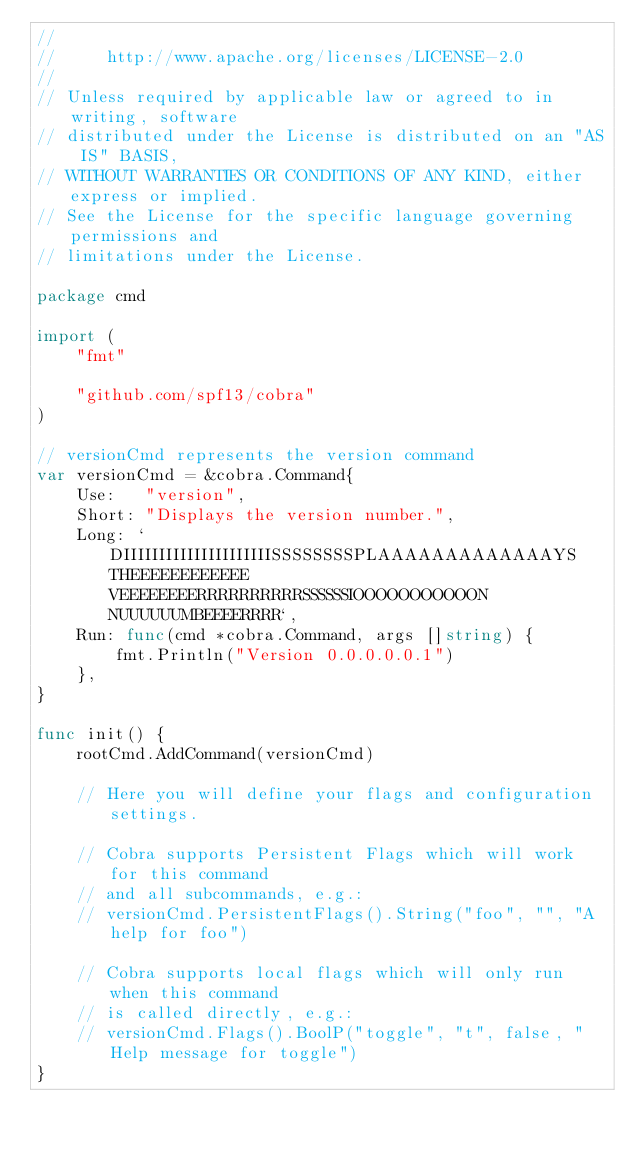<code> <loc_0><loc_0><loc_500><loc_500><_Go_>//
//     http://www.apache.org/licenses/LICENSE-2.0
//
// Unless required by applicable law or agreed to in writing, software
// distributed under the License is distributed on an "AS IS" BASIS,
// WITHOUT WARRANTIES OR CONDITIONS OF ANY KIND, either express or implied.
// See the License for the specific language governing permissions and
// limitations under the License.

package cmd

import (
	"fmt"

	"github.com/spf13/cobra"
)

// versionCmd represents the version command
var versionCmd = &cobra.Command{
	Use:   "version",
	Short: "Displays the version number.",
	Long: `DIIIIIIIIIIIIIIIIIIIIISSSSSSSSPLAAAAAAAAAAAAAYS THEEEEEEEEEEEE VEEEEEEEERRRRRRRRRRSSSSSSIOOOOOOOOOOON NUUUUUUMBEEEERRRR`,
	Run: func(cmd *cobra.Command, args []string) {
		fmt.Println("Version 0.0.0.0.0.1")
	},
}

func init() {
	rootCmd.AddCommand(versionCmd)

	// Here you will define your flags and configuration settings.

	// Cobra supports Persistent Flags which will work for this command
	// and all subcommands, e.g.:
	// versionCmd.PersistentFlags().String("foo", "", "A help for foo")

	// Cobra supports local flags which will only run when this command
	// is called directly, e.g.:
	// versionCmd.Flags().BoolP("toggle", "t", false, "Help message for toggle")
}
</code> 